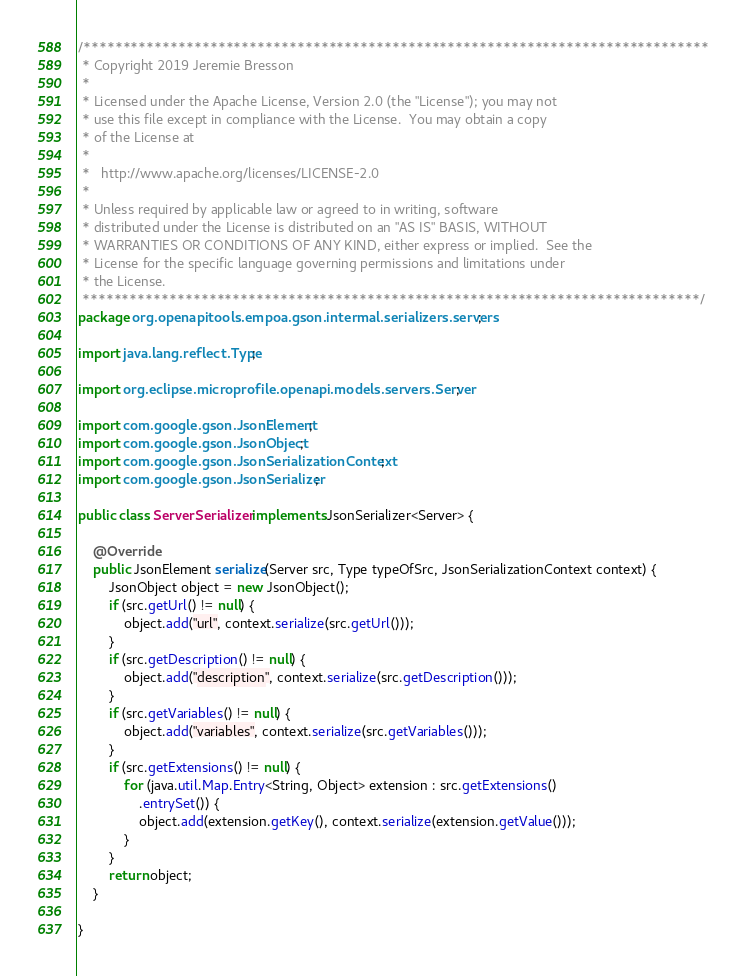Convert code to text. <code><loc_0><loc_0><loc_500><loc_500><_Java_>/*******************************************************************************
 * Copyright 2019 Jeremie Bresson
 * 
 * Licensed under the Apache License, Version 2.0 (the "License"); you may not
 * use this file except in compliance with the License.  You may obtain a copy
 * of the License at
 * 
 *   http://www.apache.org/licenses/LICENSE-2.0
 * 
 * Unless required by applicable law or agreed to in writing, software
 * distributed under the License is distributed on an "AS IS" BASIS, WITHOUT
 * WARRANTIES OR CONDITIONS OF ANY KIND, either express or implied.  See the
 * License for the specific language governing permissions and limitations under
 * the License.
 ******************************************************************************/
package org.openapitools.empoa.gson.intermal.serializers.servers;

import java.lang.reflect.Type;

import org.eclipse.microprofile.openapi.models.servers.Server;

import com.google.gson.JsonElement;
import com.google.gson.JsonObject;
import com.google.gson.JsonSerializationContext;
import com.google.gson.JsonSerializer;

public class ServerSerializer implements JsonSerializer<Server> {

    @Override
    public JsonElement serialize(Server src, Type typeOfSrc, JsonSerializationContext context) {
        JsonObject object = new JsonObject();
        if (src.getUrl() != null) {
            object.add("url", context.serialize(src.getUrl()));
        }
        if (src.getDescription() != null) {
            object.add("description", context.serialize(src.getDescription()));
        }
        if (src.getVariables() != null) {
            object.add("variables", context.serialize(src.getVariables()));
        }
        if (src.getExtensions() != null) {
            for (java.util.Map.Entry<String, Object> extension : src.getExtensions()
                .entrySet()) {
                object.add(extension.getKey(), context.serialize(extension.getValue()));
            }
        }
        return object;
    }

}
</code> 